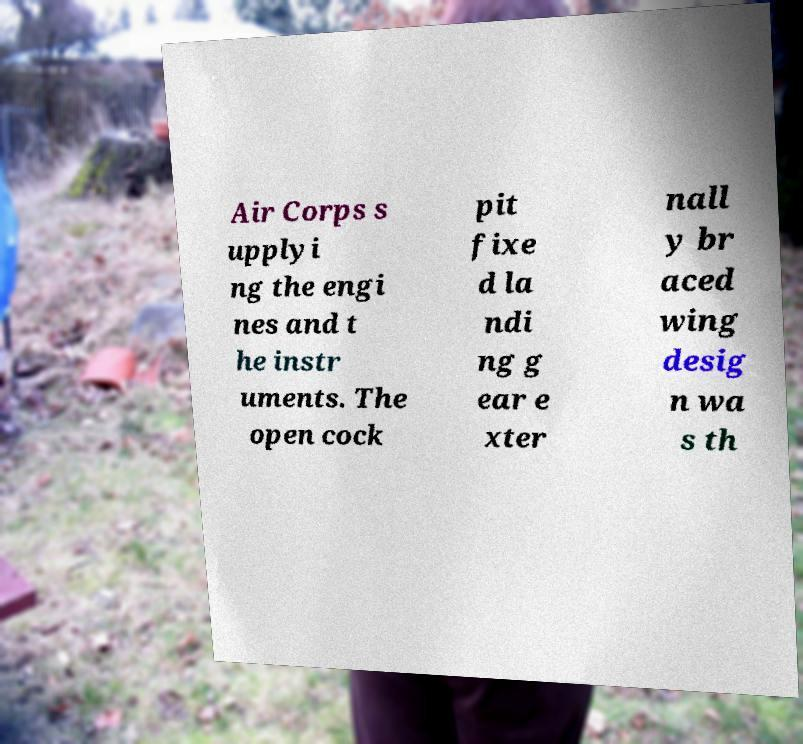Could you assist in decoding the text presented in this image and type it out clearly? Air Corps s upplyi ng the engi nes and t he instr uments. The open cock pit fixe d la ndi ng g ear e xter nall y br aced wing desig n wa s th 